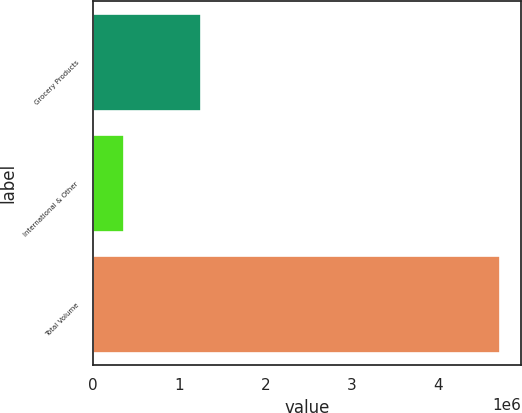Convert chart to OTSL. <chart><loc_0><loc_0><loc_500><loc_500><bar_chart><fcel>Grocery Products<fcel>International & Other<fcel>Total Volume<nl><fcel>1.25478e+06<fcel>355064<fcel>4.72164e+06<nl></chart> 